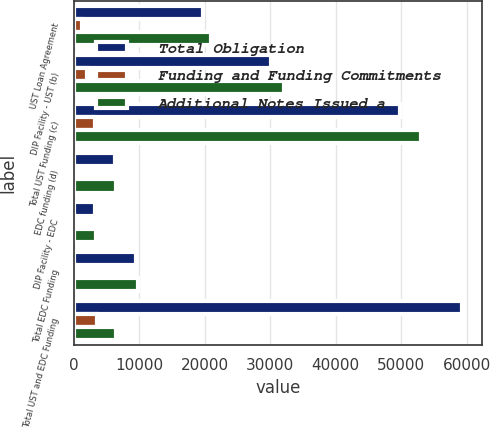Convert chart. <chart><loc_0><loc_0><loc_500><loc_500><stacked_bar_chart><ecel><fcel>UST Loan Agreement<fcel>DIP Facility - UST (b)<fcel>Total UST Funding (c)<fcel>EDC funding (d)<fcel>DIP Facility - EDC<fcel>Total EDC Funding<fcel>Total UST and EDC Funding<nl><fcel>Total Obligation<fcel>19761<fcel>30100<fcel>49861<fcel>6294<fcel>3200<fcel>9494<fcel>59355<nl><fcel>Funding and Funding Commitments<fcel>1172<fcel>2008<fcel>3180<fcel>161<fcel>213<fcel>374<fcel>3554<nl><fcel>Additional Notes Issued a<fcel>20933<fcel>32108<fcel>53041<fcel>6455<fcel>3413<fcel>9868<fcel>6374.5<nl></chart> 